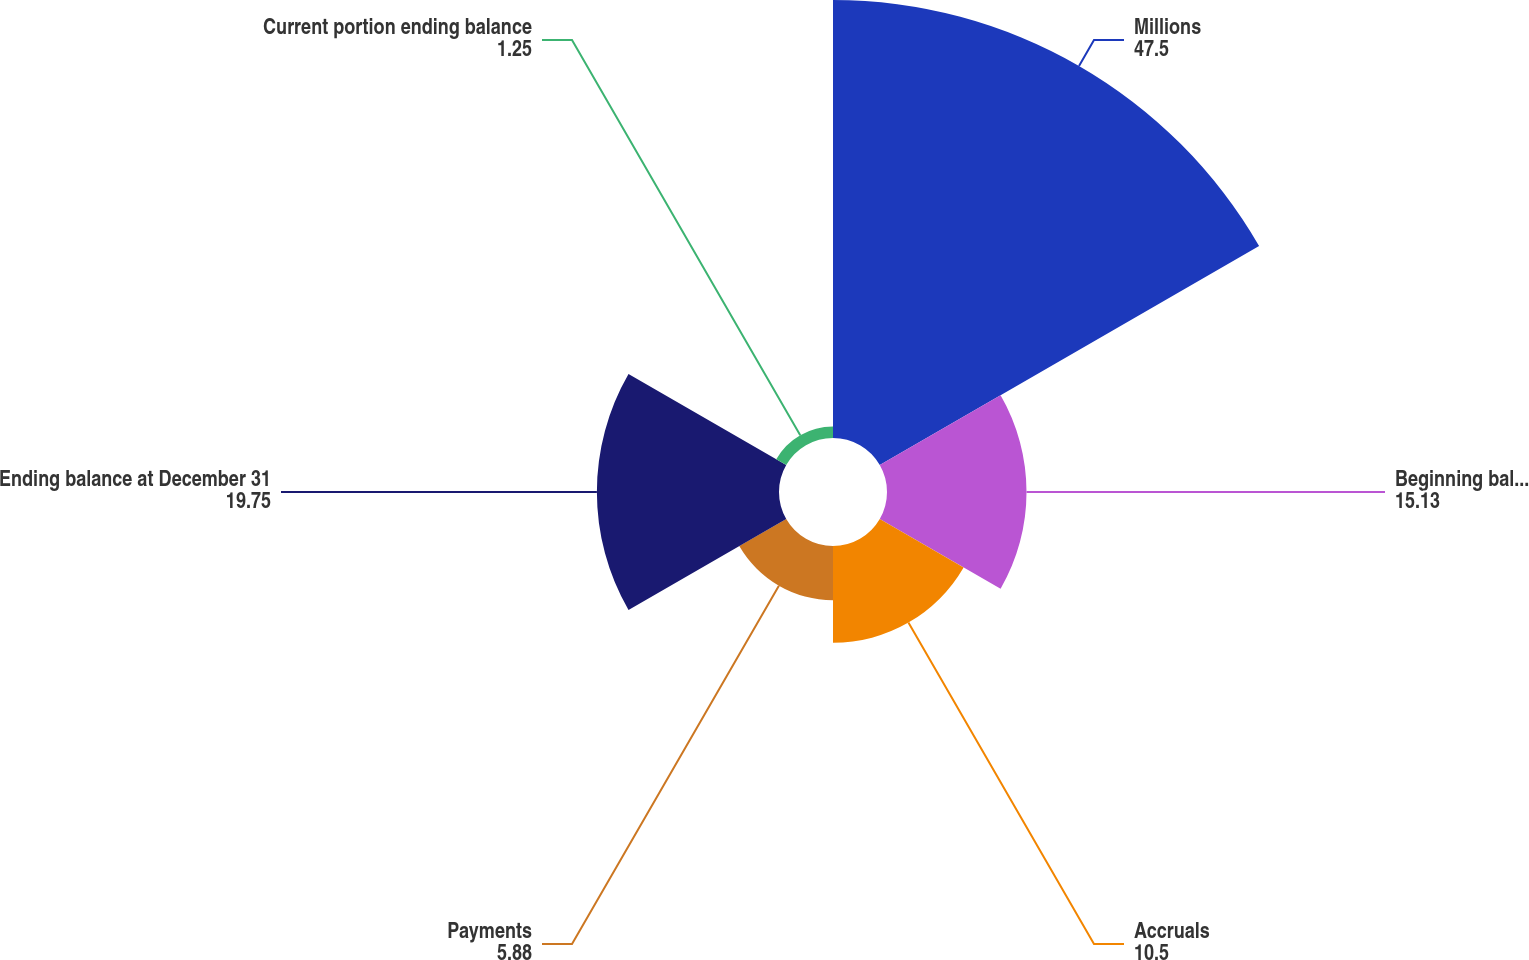Convert chart to OTSL. <chart><loc_0><loc_0><loc_500><loc_500><pie_chart><fcel>Millions<fcel>Beginning balance<fcel>Accruals<fcel>Payments<fcel>Ending balance at December 31<fcel>Current portion ending balance<nl><fcel>47.5%<fcel>15.13%<fcel>10.5%<fcel>5.88%<fcel>19.75%<fcel>1.25%<nl></chart> 